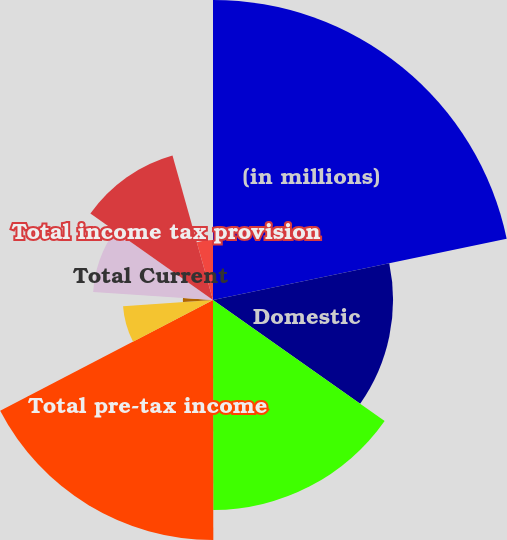Convert chart to OTSL. <chart><loc_0><loc_0><loc_500><loc_500><pie_chart><fcel>(in millions)<fcel>Domestic<fcel>Foreign<fcel>Total pre-tax income<fcel>Domestic - federal<fcel>Domestic - state and local<fcel>Total Current<fcel>Total Deferred<fcel>Total income tax provision<fcel>Effective income tax rate<nl><fcel>21.73%<fcel>13.04%<fcel>15.21%<fcel>17.38%<fcel>6.53%<fcel>2.18%<fcel>8.7%<fcel>0.01%<fcel>10.87%<fcel>4.35%<nl></chart> 